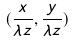<formula> <loc_0><loc_0><loc_500><loc_500>( \frac { x } { \lambda z } , \frac { y } { \lambda z } )</formula> 